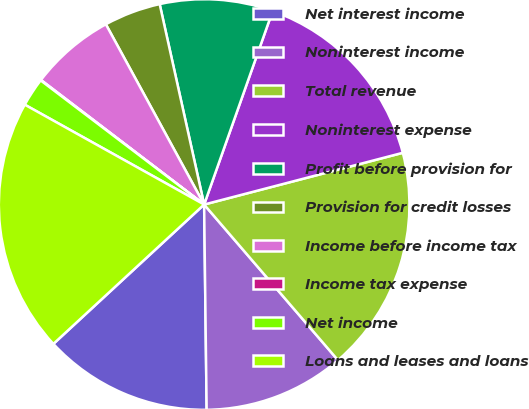Convert chart. <chart><loc_0><loc_0><loc_500><loc_500><pie_chart><fcel>Net interest income<fcel>Noninterest income<fcel>Total revenue<fcel>Noninterest expense<fcel>Profit before provision for<fcel>Provision for credit losses<fcel>Income before income tax<fcel>Income tax expense<fcel>Net income<fcel>Loans and leases and loans<nl><fcel>13.32%<fcel>11.11%<fcel>17.75%<fcel>15.53%<fcel>8.89%<fcel>4.47%<fcel>6.68%<fcel>0.04%<fcel>2.25%<fcel>19.96%<nl></chart> 